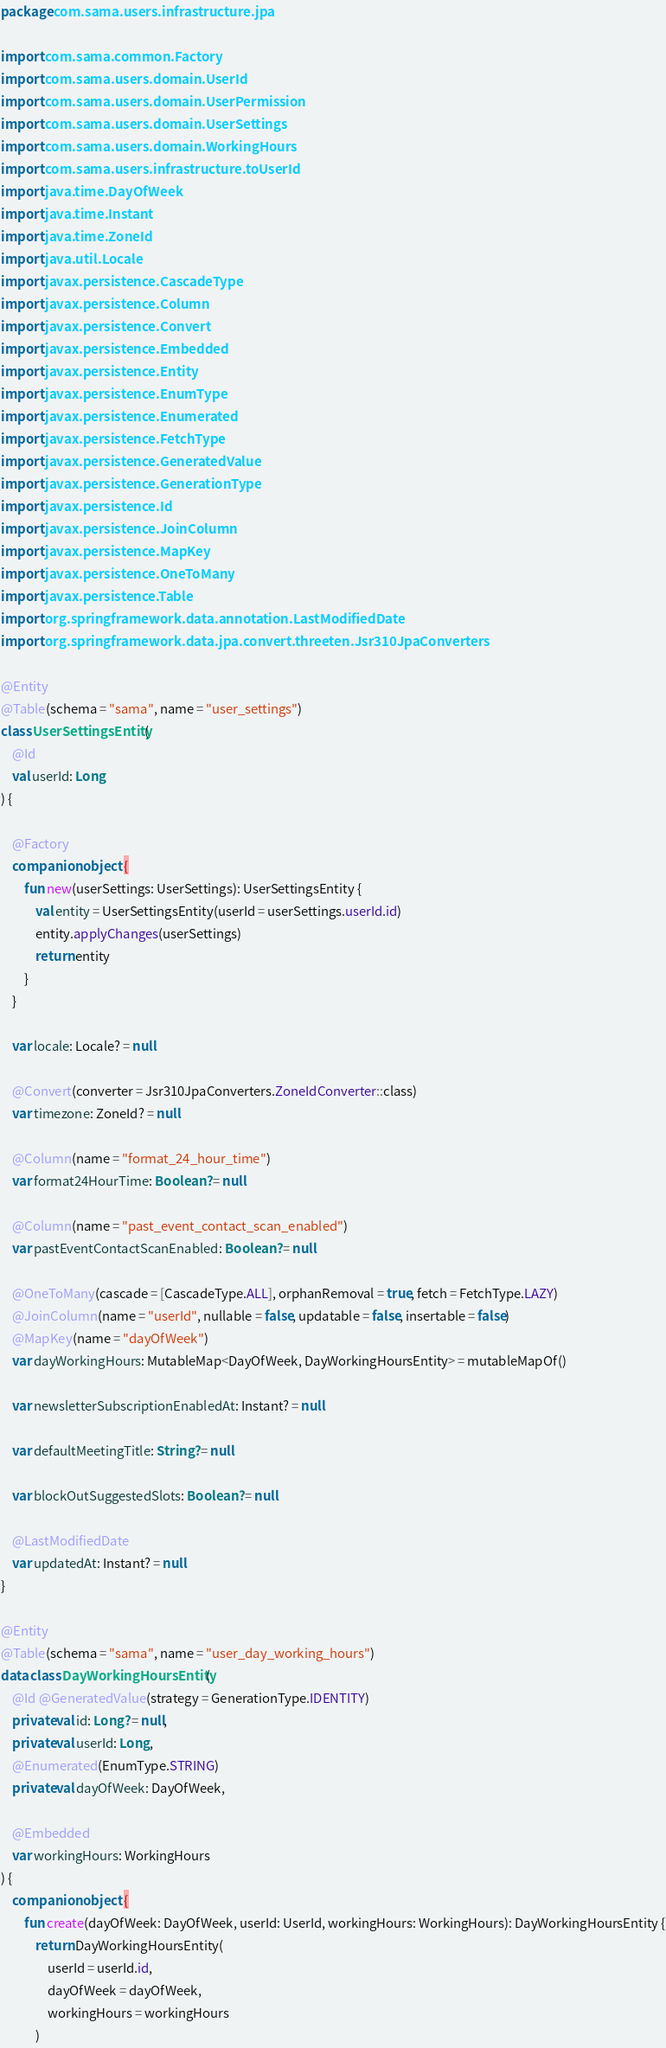Convert code to text. <code><loc_0><loc_0><loc_500><loc_500><_Kotlin_>package com.sama.users.infrastructure.jpa

import com.sama.common.Factory
import com.sama.users.domain.UserId
import com.sama.users.domain.UserPermission
import com.sama.users.domain.UserSettings
import com.sama.users.domain.WorkingHours
import com.sama.users.infrastructure.toUserId
import java.time.DayOfWeek
import java.time.Instant
import java.time.ZoneId
import java.util.Locale
import javax.persistence.CascadeType
import javax.persistence.Column
import javax.persistence.Convert
import javax.persistence.Embedded
import javax.persistence.Entity
import javax.persistence.EnumType
import javax.persistence.Enumerated
import javax.persistence.FetchType
import javax.persistence.GeneratedValue
import javax.persistence.GenerationType
import javax.persistence.Id
import javax.persistence.JoinColumn
import javax.persistence.MapKey
import javax.persistence.OneToMany
import javax.persistence.Table
import org.springframework.data.annotation.LastModifiedDate
import org.springframework.data.jpa.convert.threeten.Jsr310JpaConverters

@Entity
@Table(schema = "sama", name = "user_settings")
class UserSettingsEntity(
    @Id
    val userId: Long
) {

    @Factory
    companion object {
        fun new(userSettings: UserSettings): UserSettingsEntity {
            val entity = UserSettingsEntity(userId = userSettings.userId.id)
            entity.applyChanges(userSettings)
            return entity
        }
    }

    var locale: Locale? = null

    @Convert(converter = Jsr310JpaConverters.ZoneIdConverter::class)
    var timezone: ZoneId? = null

    @Column(name = "format_24_hour_time")
    var format24HourTime: Boolean? = null

    @Column(name = "past_event_contact_scan_enabled")
    var pastEventContactScanEnabled: Boolean? = null

    @OneToMany(cascade = [CascadeType.ALL], orphanRemoval = true, fetch = FetchType.LAZY)
    @JoinColumn(name = "userId", nullable = false, updatable = false, insertable = false)
    @MapKey(name = "dayOfWeek")
    var dayWorkingHours: MutableMap<DayOfWeek, DayWorkingHoursEntity> = mutableMapOf()

    var newsletterSubscriptionEnabledAt: Instant? = null

    var defaultMeetingTitle: String? = null

    var blockOutSuggestedSlots: Boolean? = null

    @LastModifiedDate
    var updatedAt: Instant? = null
}

@Entity
@Table(schema = "sama", name = "user_day_working_hours")
data class DayWorkingHoursEntity(
    @Id @GeneratedValue(strategy = GenerationType.IDENTITY)
    private val id: Long? = null,
    private val userId: Long,
    @Enumerated(EnumType.STRING)
    private val dayOfWeek: DayOfWeek,

    @Embedded
    var workingHours: WorkingHours
) {
    companion object {
        fun create(dayOfWeek: DayOfWeek, userId: UserId, workingHours: WorkingHours): DayWorkingHoursEntity {
            return DayWorkingHoursEntity(
                userId = userId.id,
                dayOfWeek = dayOfWeek,
                workingHours = workingHours
            )</code> 